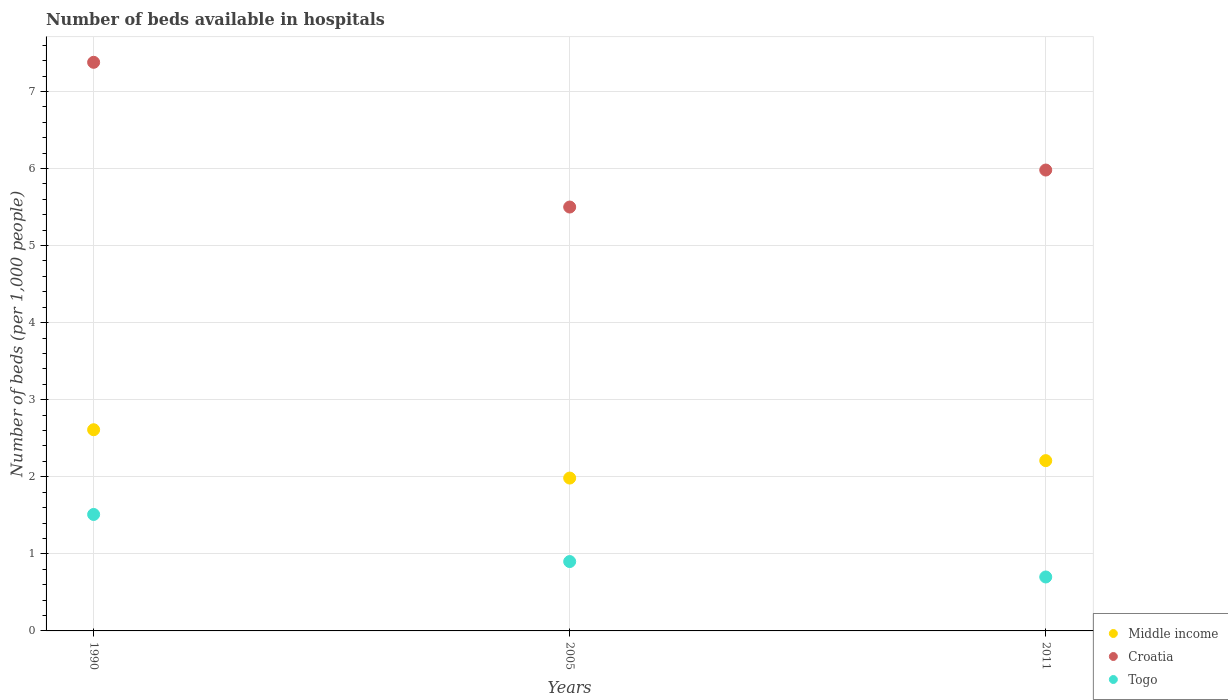Is the number of dotlines equal to the number of legend labels?
Provide a short and direct response. Yes. What is the number of beds in the hospiatls of in Croatia in 1990?
Offer a terse response. 7.38. Across all years, what is the maximum number of beds in the hospiatls of in Croatia?
Make the answer very short. 7.38. Across all years, what is the minimum number of beds in the hospiatls of in Togo?
Ensure brevity in your answer.  0.7. What is the total number of beds in the hospiatls of in Togo in the graph?
Keep it short and to the point. 3.11. What is the difference between the number of beds in the hospiatls of in Togo in 2005 and that in 2011?
Offer a very short reply. 0.2. What is the difference between the number of beds in the hospiatls of in Togo in 2005 and the number of beds in the hospiatls of in Middle income in 1990?
Your answer should be compact. -1.71. What is the average number of beds in the hospiatls of in Middle income per year?
Provide a short and direct response. 2.27. In the year 1990, what is the difference between the number of beds in the hospiatls of in Croatia and number of beds in the hospiatls of in Togo?
Provide a short and direct response. 5.87. What is the ratio of the number of beds in the hospiatls of in Croatia in 1990 to that in 2005?
Offer a terse response. 1.34. What is the difference between the highest and the second highest number of beds in the hospiatls of in Togo?
Keep it short and to the point. 0.61. What is the difference between the highest and the lowest number of beds in the hospiatls of in Middle income?
Give a very brief answer. 0.63. Is the sum of the number of beds in the hospiatls of in Middle income in 1990 and 2011 greater than the maximum number of beds in the hospiatls of in Togo across all years?
Provide a short and direct response. Yes. Is it the case that in every year, the sum of the number of beds in the hospiatls of in Middle income and number of beds in the hospiatls of in Togo  is greater than the number of beds in the hospiatls of in Croatia?
Offer a terse response. No. Does the number of beds in the hospiatls of in Togo monotonically increase over the years?
Offer a terse response. No. Is the number of beds in the hospiatls of in Croatia strictly less than the number of beds in the hospiatls of in Middle income over the years?
Offer a terse response. No. How many years are there in the graph?
Your answer should be very brief. 3. What is the difference between two consecutive major ticks on the Y-axis?
Provide a succinct answer. 1. Are the values on the major ticks of Y-axis written in scientific E-notation?
Provide a short and direct response. No. Where does the legend appear in the graph?
Provide a short and direct response. Bottom right. What is the title of the graph?
Offer a terse response. Number of beds available in hospitals. Does "North America" appear as one of the legend labels in the graph?
Make the answer very short. No. What is the label or title of the Y-axis?
Offer a terse response. Number of beds (per 1,0 people). What is the Number of beds (per 1,000 people) of Middle income in 1990?
Offer a terse response. 2.61. What is the Number of beds (per 1,000 people) of Croatia in 1990?
Your response must be concise. 7.38. What is the Number of beds (per 1,000 people) in Togo in 1990?
Your response must be concise. 1.51. What is the Number of beds (per 1,000 people) of Middle income in 2005?
Offer a very short reply. 1.98. What is the Number of beds (per 1,000 people) in Croatia in 2005?
Give a very brief answer. 5.5. What is the Number of beds (per 1,000 people) of Togo in 2005?
Provide a succinct answer. 0.9. What is the Number of beds (per 1,000 people) in Middle income in 2011?
Your answer should be very brief. 2.21. What is the Number of beds (per 1,000 people) of Croatia in 2011?
Give a very brief answer. 5.98. What is the Number of beds (per 1,000 people) of Togo in 2011?
Offer a very short reply. 0.7. Across all years, what is the maximum Number of beds (per 1,000 people) in Middle income?
Your response must be concise. 2.61. Across all years, what is the maximum Number of beds (per 1,000 people) in Croatia?
Offer a very short reply. 7.38. Across all years, what is the maximum Number of beds (per 1,000 people) in Togo?
Offer a terse response. 1.51. Across all years, what is the minimum Number of beds (per 1,000 people) in Middle income?
Provide a short and direct response. 1.98. What is the total Number of beds (per 1,000 people) in Middle income in the graph?
Keep it short and to the point. 6.8. What is the total Number of beds (per 1,000 people) in Croatia in the graph?
Keep it short and to the point. 18.86. What is the total Number of beds (per 1,000 people) in Togo in the graph?
Your answer should be compact. 3.11. What is the difference between the Number of beds (per 1,000 people) in Middle income in 1990 and that in 2005?
Offer a terse response. 0.63. What is the difference between the Number of beds (per 1,000 people) in Croatia in 1990 and that in 2005?
Your answer should be very brief. 1.88. What is the difference between the Number of beds (per 1,000 people) of Togo in 1990 and that in 2005?
Your answer should be very brief. 0.61. What is the difference between the Number of beds (per 1,000 people) of Middle income in 1990 and that in 2011?
Keep it short and to the point. 0.4. What is the difference between the Number of beds (per 1,000 people) of Croatia in 1990 and that in 2011?
Make the answer very short. 1.4. What is the difference between the Number of beds (per 1,000 people) in Togo in 1990 and that in 2011?
Provide a short and direct response. 0.81. What is the difference between the Number of beds (per 1,000 people) of Middle income in 2005 and that in 2011?
Give a very brief answer. -0.23. What is the difference between the Number of beds (per 1,000 people) in Croatia in 2005 and that in 2011?
Give a very brief answer. -0.48. What is the difference between the Number of beds (per 1,000 people) of Togo in 2005 and that in 2011?
Your answer should be compact. 0.2. What is the difference between the Number of beds (per 1,000 people) in Middle income in 1990 and the Number of beds (per 1,000 people) in Croatia in 2005?
Your answer should be very brief. -2.89. What is the difference between the Number of beds (per 1,000 people) in Middle income in 1990 and the Number of beds (per 1,000 people) in Togo in 2005?
Offer a terse response. 1.71. What is the difference between the Number of beds (per 1,000 people) of Croatia in 1990 and the Number of beds (per 1,000 people) of Togo in 2005?
Your response must be concise. 6.48. What is the difference between the Number of beds (per 1,000 people) in Middle income in 1990 and the Number of beds (per 1,000 people) in Croatia in 2011?
Give a very brief answer. -3.37. What is the difference between the Number of beds (per 1,000 people) in Middle income in 1990 and the Number of beds (per 1,000 people) in Togo in 2011?
Your response must be concise. 1.91. What is the difference between the Number of beds (per 1,000 people) in Croatia in 1990 and the Number of beds (per 1,000 people) in Togo in 2011?
Provide a succinct answer. 6.68. What is the difference between the Number of beds (per 1,000 people) of Middle income in 2005 and the Number of beds (per 1,000 people) of Croatia in 2011?
Your answer should be very brief. -4. What is the difference between the Number of beds (per 1,000 people) of Middle income in 2005 and the Number of beds (per 1,000 people) of Togo in 2011?
Provide a succinct answer. 1.28. What is the average Number of beds (per 1,000 people) in Middle income per year?
Give a very brief answer. 2.27. What is the average Number of beds (per 1,000 people) in Croatia per year?
Keep it short and to the point. 6.29. In the year 1990, what is the difference between the Number of beds (per 1,000 people) of Middle income and Number of beds (per 1,000 people) of Croatia?
Provide a succinct answer. -4.77. In the year 1990, what is the difference between the Number of beds (per 1,000 people) of Middle income and Number of beds (per 1,000 people) of Togo?
Ensure brevity in your answer.  1.1. In the year 1990, what is the difference between the Number of beds (per 1,000 people) of Croatia and Number of beds (per 1,000 people) of Togo?
Ensure brevity in your answer.  5.87. In the year 2005, what is the difference between the Number of beds (per 1,000 people) of Middle income and Number of beds (per 1,000 people) of Croatia?
Your response must be concise. -3.52. In the year 2005, what is the difference between the Number of beds (per 1,000 people) of Middle income and Number of beds (per 1,000 people) of Togo?
Give a very brief answer. 1.08. In the year 2011, what is the difference between the Number of beds (per 1,000 people) of Middle income and Number of beds (per 1,000 people) of Croatia?
Offer a very short reply. -3.77. In the year 2011, what is the difference between the Number of beds (per 1,000 people) in Middle income and Number of beds (per 1,000 people) in Togo?
Your response must be concise. 1.51. In the year 2011, what is the difference between the Number of beds (per 1,000 people) of Croatia and Number of beds (per 1,000 people) of Togo?
Offer a terse response. 5.28. What is the ratio of the Number of beds (per 1,000 people) in Middle income in 1990 to that in 2005?
Your answer should be compact. 1.32. What is the ratio of the Number of beds (per 1,000 people) in Croatia in 1990 to that in 2005?
Your answer should be compact. 1.34. What is the ratio of the Number of beds (per 1,000 people) in Togo in 1990 to that in 2005?
Provide a succinct answer. 1.68. What is the ratio of the Number of beds (per 1,000 people) of Middle income in 1990 to that in 2011?
Your answer should be very brief. 1.18. What is the ratio of the Number of beds (per 1,000 people) of Croatia in 1990 to that in 2011?
Give a very brief answer. 1.23. What is the ratio of the Number of beds (per 1,000 people) of Togo in 1990 to that in 2011?
Make the answer very short. 2.16. What is the ratio of the Number of beds (per 1,000 people) of Middle income in 2005 to that in 2011?
Offer a very short reply. 0.9. What is the ratio of the Number of beds (per 1,000 people) in Croatia in 2005 to that in 2011?
Offer a terse response. 0.92. What is the difference between the highest and the second highest Number of beds (per 1,000 people) in Middle income?
Offer a very short reply. 0.4. What is the difference between the highest and the second highest Number of beds (per 1,000 people) of Croatia?
Give a very brief answer. 1.4. What is the difference between the highest and the second highest Number of beds (per 1,000 people) of Togo?
Give a very brief answer. 0.61. What is the difference between the highest and the lowest Number of beds (per 1,000 people) of Middle income?
Ensure brevity in your answer.  0.63. What is the difference between the highest and the lowest Number of beds (per 1,000 people) of Croatia?
Make the answer very short. 1.88. What is the difference between the highest and the lowest Number of beds (per 1,000 people) of Togo?
Provide a short and direct response. 0.81. 